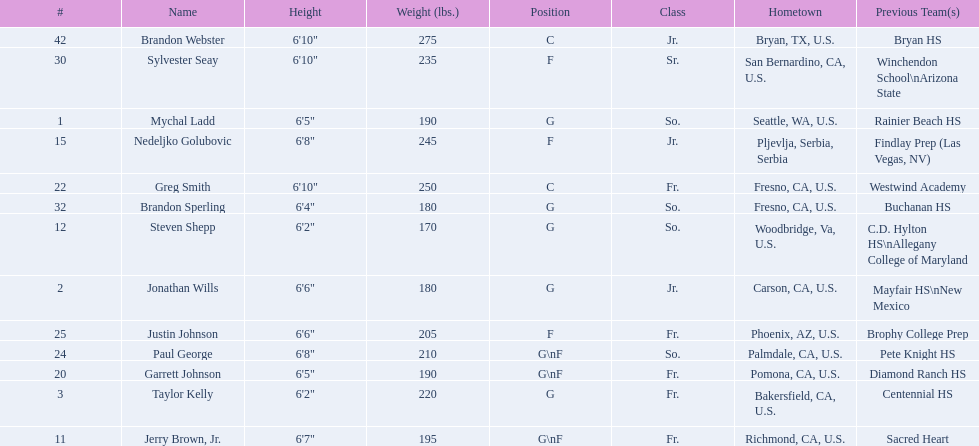Who are all the players? Mychal Ladd, Jonathan Wills, Taylor Kelly, Jerry Brown, Jr., Steven Shepp, Nedeljko Golubovic, Garrett Johnson, Greg Smith, Paul George, Justin Johnson, Sylvester Seay, Brandon Sperling, Brandon Webster. How tall are they? 6'5", 6'6", 6'2", 6'7", 6'2", 6'8", 6'5", 6'10", 6'8", 6'6", 6'10", 6'4", 6'10". What about just paul george and greg smitih? 6'10", 6'8". And which of the two is taller? Greg Smith. 